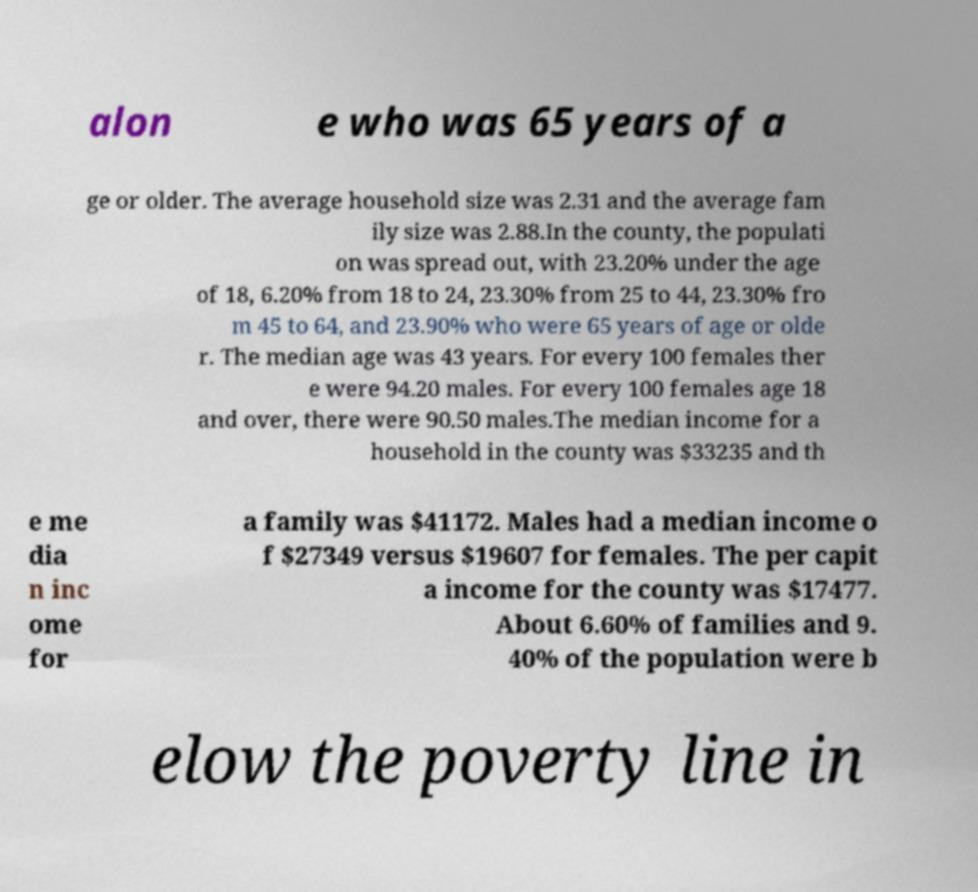Please identify and transcribe the text found in this image. alon e who was 65 years of a ge or older. The average household size was 2.31 and the average fam ily size was 2.88.In the county, the populati on was spread out, with 23.20% under the age of 18, 6.20% from 18 to 24, 23.30% from 25 to 44, 23.30% fro m 45 to 64, and 23.90% who were 65 years of age or olde r. The median age was 43 years. For every 100 females ther e were 94.20 males. For every 100 females age 18 and over, there were 90.50 males.The median income for a household in the county was $33235 and th e me dia n inc ome for a family was $41172. Males had a median income o f $27349 versus $19607 for females. The per capit a income for the county was $17477. About 6.60% of families and 9. 40% of the population were b elow the poverty line in 